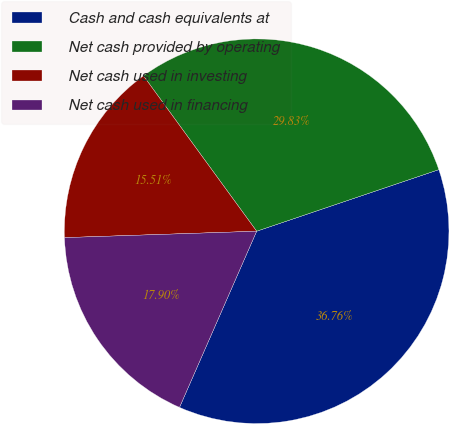Convert chart to OTSL. <chart><loc_0><loc_0><loc_500><loc_500><pie_chart><fcel>Cash and cash equivalents at<fcel>Net cash provided by operating<fcel>Net cash used in investing<fcel>Net cash used in financing<nl><fcel>36.76%<fcel>29.83%<fcel>15.51%<fcel>17.9%<nl></chart> 